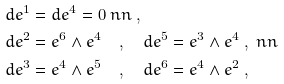<formula> <loc_0><loc_0><loc_500><loc_500>& d e ^ { 1 } = d e ^ { 4 } = 0 \ n n \ , \\ & d e ^ { 2 } = e ^ { 6 } \wedge e ^ { 4 } \quad , \quad d e ^ { 5 } = e ^ { 3 } \wedge e ^ { 4 } \ , \ n n \\ & d e ^ { 3 } = e ^ { 4 } \wedge e ^ { 5 } \quad , \quad d e ^ { 6 } = e ^ { 4 } \wedge e ^ { 2 } \ ,</formula> 